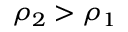Convert formula to latex. <formula><loc_0><loc_0><loc_500><loc_500>\rho _ { 2 } > \rho _ { 1 }</formula> 